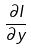<formula> <loc_0><loc_0><loc_500><loc_500>\frac { \partial I } { \partial y }</formula> 